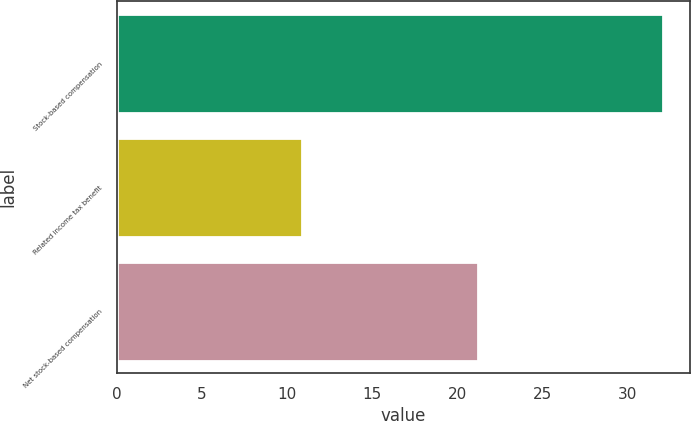Convert chart to OTSL. <chart><loc_0><loc_0><loc_500><loc_500><bar_chart><fcel>Stock-based compensation<fcel>Related income tax benefit<fcel>Net stock-based compensation<nl><fcel>32.1<fcel>10.9<fcel>21.2<nl></chart> 